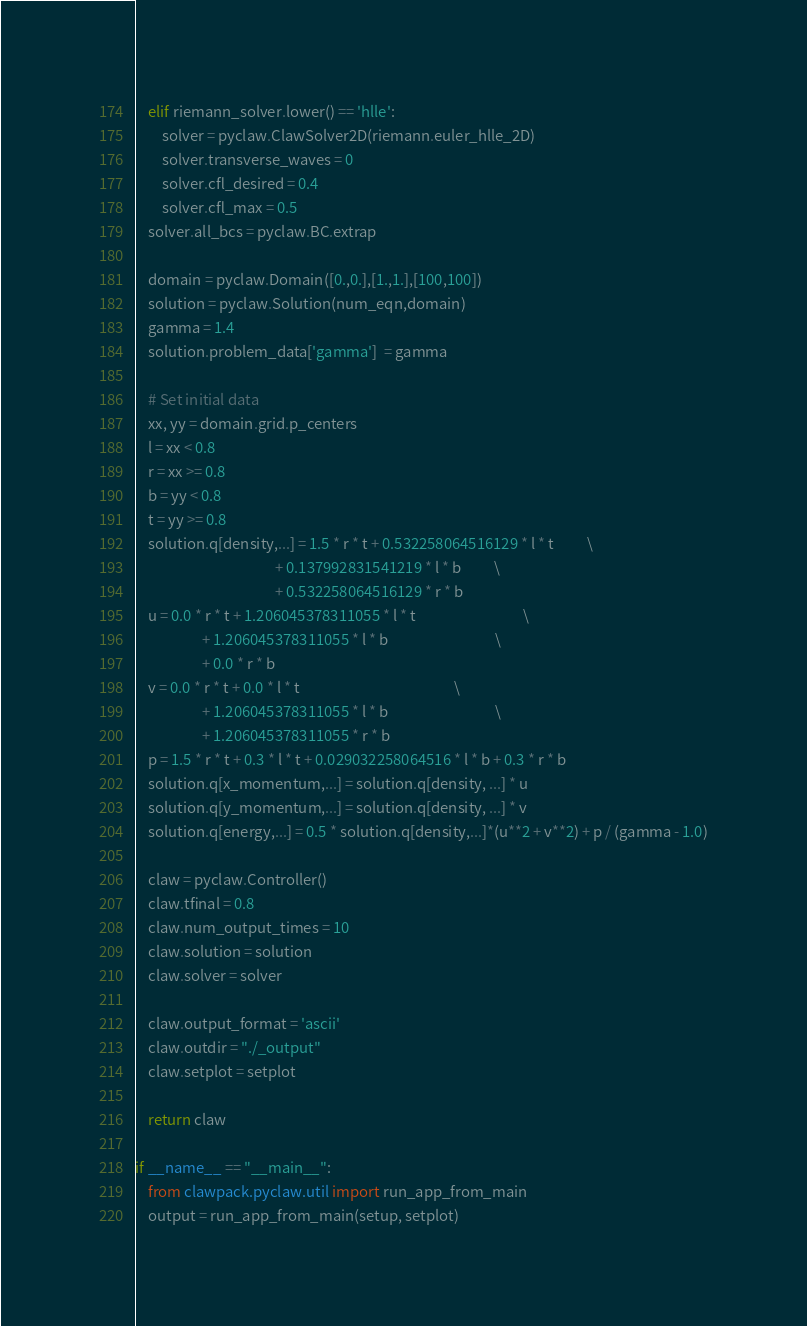Convert code to text. <code><loc_0><loc_0><loc_500><loc_500><_Python_>    elif riemann_solver.lower() == 'hlle':
        solver = pyclaw.ClawSolver2D(riemann.euler_hlle_2D)
        solver.transverse_waves = 0
        solver.cfl_desired = 0.4
        solver.cfl_max = 0.5
    solver.all_bcs = pyclaw.BC.extrap

    domain = pyclaw.Domain([0.,0.],[1.,1.],[100,100])
    solution = pyclaw.Solution(num_eqn,domain)
    gamma = 1.4
    solution.problem_data['gamma']  = gamma

    # Set initial data
    xx, yy = domain.grid.p_centers
    l = xx < 0.8
    r = xx >= 0.8
    b = yy < 0.8
    t = yy >= 0.8
    solution.q[density,...] = 1.5 * r * t + 0.532258064516129 * l * t          \
                                          + 0.137992831541219 * l * b          \
                                          + 0.532258064516129 * r * b
    u = 0.0 * r * t + 1.206045378311055 * l * t                                \
                    + 1.206045378311055 * l * b                                \
                    + 0.0 * r * b
    v = 0.0 * r * t + 0.0 * l * t                                              \
                    + 1.206045378311055 * l * b                                \
                    + 1.206045378311055 * r * b
    p = 1.5 * r * t + 0.3 * l * t + 0.029032258064516 * l * b + 0.3 * r * b
    solution.q[x_momentum,...] = solution.q[density, ...] * u
    solution.q[y_momentum,...] = solution.q[density, ...] * v
    solution.q[energy,...] = 0.5 * solution.q[density,...]*(u**2 + v**2) + p / (gamma - 1.0)

    claw = pyclaw.Controller()
    claw.tfinal = 0.8
    claw.num_output_times = 10
    claw.solution = solution
    claw.solver = solver

    claw.output_format = 'ascii'    
    claw.outdir = "./_output"
    claw.setplot = setplot

    return claw

if __name__ == "__main__":
    from clawpack.pyclaw.util import run_app_from_main
    output = run_app_from_main(setup, setplot)
</code> 